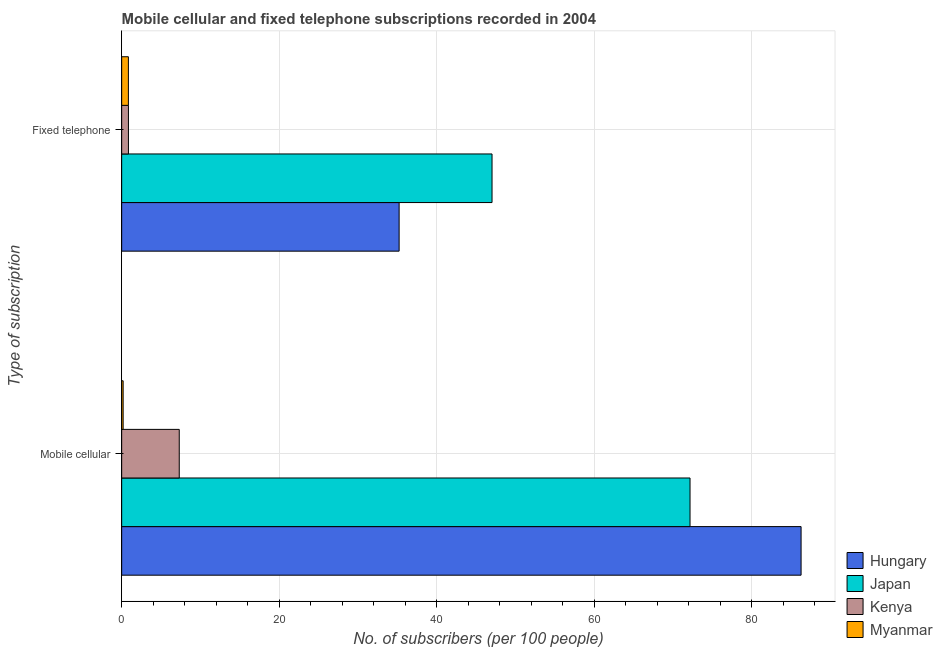Are the number of bars on each tick of the Y-axis equal?
Give a very brief answer. Yes. How many bars are there on the 1st tick from the top?
Your response must be concise. 4. What is the label of the 2nd group of bars from the top?
Offer a terse response. Mobile cellular. What is the number of fixed telephone subscribers in Hungary?
Offer a very short reply. 35.22. Across all countries, what is the maximum number of fixed telephone subscribers?
Make the answer very short. 47.02. Across all countries, what is the minimum number of fixed telephone subscribers?
Provide a succinct answer. 0.85. In which country was the number of fixed telephone subscribers maximum?
Your answer should be compact. Japan. In which country was the number of fixed telephone subscribers minimum?
Your answer should be compact. Myanmar. What is the total number of mobile cellular subscribers in the graph?
Your answer should be very brief. 165.91. What is the difference between the number of fixed telephone subscribers in Japan and that in Hungary?
Give a very brief answer. 11.79. What is the difference between the number of mobile cellular subscribers in Hungary and the number of fixed telephone subscribers in Japan?
Give a very brief answer. 39.24. What is the average number of mobile cellular subscribers per country?
Your answer should be compact. 41.48. What is the difference between the number of mobile cellular subscribers and number of fixed telephone subscribers in Kenya?
Provide a short and direct response. 6.45. In how many countries, is the number of fixed telephone subscribers greater than 24 ?
Your answer should be compact. 2. What is the ratio of the number of fixed telephone subscribers in Myanmar to that in Kenya?
Provide a succinct answer. 0.99. What does the 3rd bar from the bottom in Fixed telephone represents?
Offer a very short reply. Kenya. What is the difference between two consecutive major ticks on the X-axis?
Provide a short and direct response. 20. Does the graph contain any zero values?
Your response must be concise. No. How many legend labels are there?
Provide a short and direct response. 4. How are the legend labels stacked?
Provide a short and direct response. Vertical. What is the title of the graph?
Make the answer very short. Mobile cellular and fixed telephone subscriptions recorded in 2004. What is the label or title of the X-axis?
Offer a terse response. No. of subscribers (per 100 people). What is the label or title of the Y-axis?
Make the answer very short. Type of subscription. What is the No. of subscribers (per 100 people) of Hungary in Mobile cellular?
Your response must be concise. 86.26. What is the No. of subscribers (per 100 people) of Japan in Mobile cellular?
Provide a succinct answer. 72.16. What is the No. of subscribers (per 100 people) in Kenya in Mobile cellular?
Your answer should be very brief. 7.31. What is the No. of subscribers (per 100 people) in Myanmar in Mobile cellular?
Offer a very short reply. 0.19. What is the No. of subscribers (per 100 people) in Hungary in Fixed telephone?
Offer a very short reply. 35.22. What is the No. of subscribers (per 100 people) of Japan in Fixed telephone?
Give a very brief answer. 47.02. What is the No. of subscribers (per 100 people) in Kenya in Fixed telephone?
Give a very brief answer. 0.86. What is the No. of subscribers (per 100 people) in Myanmar in Fixed telephone?
Offer a terse response. 0.85. Across all Type of subscription, what is the maximum No. of subscribers (per 100 people) of Hungary?
Your answer should be very brief. 86.26. Across all Type of subscription, what is the maximum No. of subscribers (per 100 people) in Japan?
Offer a very short reply. 72.16. Across all Type of subscription, what is the maximum No. of subscribers (per 100 people) in Kenya?
Offer a very short reply. 7.31. Across all Type of subscription, what is the maximum No. of subscribers (per 100 people) in Myanmar?
Your answer should be very brief. 0.85. Across all Type of subscription, what is the minimum No. of subscribers (per 100 people) in Hungary?
Offer a terse response. 35.22. Across all Type of subscription, what is the minimum No. of subscribers (per 100 people) in Japan?
Offer a very short reply. 47.02. Across all Type of subscription, what is the minimum No. of subscribers (per 100 people) in Kenya?
Give a very brief answer. 0.86. Across all Type of subscription, what is the minimum No. of subscribers (per 100 people) in Myanmar?
Give a very brief answer. 0.19. What is the total No. of subscribers (per 100 people) of Hungary in the graph?
Your response must be concise. 121.48. What is the total No. of subscribers (per 100 people) of Japan in the graph?
Provide a succinct answer. 119.18. What is the total No. of subscribers (per 100 people) in Kenya in the graph?
Make the answer very short. 8.17. What is the total No. of subscribers (per 100 people) in Myanmar in the graph?
Give a very brief answer. 1.04. What is the difference between the No. of subscribers (per 100 people) in Hungary in Mobile cellular and that in Fixed telephone?
Keep it short and to the point. 51.03. What is the difference between the No. of subscribers (per 100 people) of Japan in Mobile cellular and that in Fixed telephone?
Make the answer very short. 25.14. What is the difference between the No. of subscribers (per 100 people) of Kenya in Mobile cellular and that in Fixed telephone?
Provide a succinct answer. 6.45. What is the difference between the No. of subscribers (per 100 people) of Myanmar in Mobile cellular and that in Fixed telephone?
Offer a terse response. -0.67. What is the difference between the No. of subscribers (per 100 people) of Hungary in Mobile cellular and the No. of subscribers (per 100 people) of Japan in Fixed telephone?
Keep it short and to the point. 39.24. What is the difference between the No. of subscribers (per 100 people) in Hungary in Mobile cellular and the No. of subscribers (per 100 people) in Kenya in Fixed telephone?
Give a very brief answer. 85.4. What is the difference between the No. of subscribers (per 100 people) in Hungary in Mobile cellular and the No. of subscribers (per 100 people) in Myanmar in Fixed telephone?
Provide a succinct answer. 85.4. What is the difference between the No. of subscribers (per 100 people) of Japan in Mobile cellular and the No. of subscribers (per 100 people) of Kenya in Fixed telephone?
Give a very brief answer. 71.3. What is the difference between the No. of subscribers (per 100 people) in Japan in Mobile cellular and the No. of subscribers (per 100 people) in Myanmar in Fixed telephone?
Your response must be concise. 71.3. What is the difference between the No. of subscribers (per 100 people) of Kenya in Mobile cellular and the No. of subscribers (per 100 people) of Myanmar in Fixed telephone?
Provide a succinct answer. 6.46. What is the average No. of subscribers (per 100 people) of Hungary per Type of subscription?
Give a very brief answer. 60.74. What is the average No. of subscribers (per 100 people) of Japan per Type of subscription?
Give a very brief answer. 59.59. What is the average No. of subscribers (per 100 people) in Kenya per Type of subscription?
Ensure brevity in your answer.  4.08. What is the average No. of subscribers (per 100 people) in Myanmar per Type of subscription?
Provide a succinct answer. 0.52. What is the difference between the No. of subscribers (per 100 people) in Hungary and No. of subscribers (per 100 people) in Japan in Mobile cellular?
Your answer should be compact. 14.1. What is the difference between the No. of subscribers (per 100 people) of Hungary and No. of subscribers (per 100 people) of Kenya in Mobile cellular?
Your answer should be very brief. 78.95. What is the difference between the No. of subscribers (per 100 people) in Hungary and No. of subscribers (per 100 people) in Myanmar in Mobile cellular?
Offer a terse response. 86.07. What is the difference between the No. of subscribers (per 100 people) of Japan and No. of subscribers (per 100 people) of Kenya in Mobile cellular?
Your answer should be compact. 64.85. What is the difference between the No. of subscribers (per 100 people) in Japan and No. of subscribers (per 100 people) in Myanmar in Mobile cellular?
Your answer should be compact. 71.97. What is the difference between the No. of subscribers (per 100 people) of Kenya and No. of subscribers (per 100 people) of Myanmar in Mobile cellular?
Ensure brevity in your answer.  7.12. What is the difference between the No. of subscribers (per 100 people) of Hungary and No. of subscribers (per 100 people) of Japan in Fixed telephone?
Your response must be concise. -11.79. What is the difference between the No. of subscribers (per 100 people) of Hungary and No. of subscribers (per 100 people) of Kenya in Fixed telephone?
Offer a terse response. 34.37. What is the difference between the No. of subscribers (per 100 people) of Hungary and No. of subscribers (per 100 people) of Myanmar in Fixed telephone?
Make the answer very short. 34.37. What is the difference between the No. of subscribers (per 100 people) of Japan and No. of subscribers (per 100 people) of Kenya in Fixed telephone?
Your answer should be compact. 46.16. What is the difference between the No. of subscribers (per 100 people) of Japan and No. of subscribers (per 100 people) of Myanmar in Fixed telephone?
Your answer should be very brief. 46.17. What is the difference between the No. of subscribers (per 100 people) of Kenya and No. of subscribers (per 100 people) of Myanmar in Fixed telephone?
Your response must be concise. 0.01. What is the ratio of the No. of subscribers (per 100 people) of Hungary in Mobile cellular to that in Fixed telephone?
Your answer should be very brief. 2.45. What is the ratio of the No. of subscribers (per 100 people) of Japan in Mobile cellular to that in Fixed telephone?
Your response must be concise. 1.53. What is the ratio of the No. of subscribers (per 100 people) of Kenya in Mobile cellular to that in Fixed telephone?
Your answer should be compact. 8.51. What is the ratio of the No. of subscribers (per 100 people) in Myanmar in Mobile cellular to that in Fixed telephone?
Offer a very short reply. 0.22. What is the difference between the highest and the second highest No. of subscribers (per 100 people) in Hungary?
Ensure brevity in your answer.  51.03. What is the difference between the highest and the second highest No. of subscribers (per 100 people) of Japan?
Give a very brief answer. 25.14. What is the difference between the highest and the second highest No. of subscribers (per 100 people) in Kenya?
Make the answer very short. 6.45. What is the difference between the highest and the second highest No. of subscribers (per 100 people) in Myanmar?
Provide a short and direct response. 0.67. What is the difference between the highest and the lowest No. of subscribers (per 100 people) of Hungary?
Your answer should be compact. 51.03. What is the difference between the highest and the lowest No. of subscribers (per 100 people) of Japan?
Offer a very short reply. 25.14. What is the difference between the highest and the lowest No. of subscribers (per 100 people) in Kenya?
Your response must be concise. 6.45. What is the difference between the highest and the lowest No. of subscribers (per 100 people) in Myanmar?
Offer a very short reply. 0.67. 